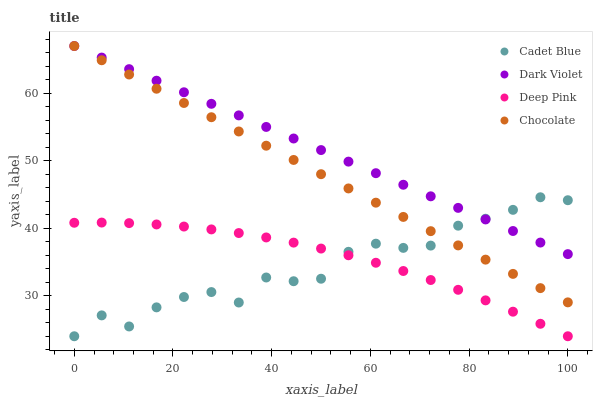Does Cadet Blue have the minimum area under the curve?
Answer yes or no. Yes. Does Dark Violet have the maximum area under the curve?
Answer yes or no. Yes. Does Dark Violet have the minimum area under the curve?
Answer yes or no. No. Does Cadet Blue have the maximum area under the curve?
Answer yes or no. No. Is Chocolate the smoothest?
Answer yes or no. Yes. Is Cadet Blue the roughest?
Answer yes or no. Yes. Is Dark Violet the smoothest?
Answer yes or no. No. Is Dark Violet the roughest?
Answer yes or no. No. Does Cadet Blue have the lowest value?
Answer yes or no. Yes. Does Dark Violet have the lowest value?
Answer yes or no. No. Does Dark Violet have the highest value?
Answer yes or no. Yes. Does Cadet Blue have the highest value?
Answer yes or no. No. Is Deep Pink less than Dark Violet?
Answer yes or no. Yes. Is Dark Violet greater than Deep Pink?
Answer yes or no. Yes. Does Deep Pink intersect Cadet Blue?
Answer yes or no. Yes. Is Deep Pink less than Cadet Blue?
Answer yes or no. No. Is Deep Pink greater than Cadet Blue?
Answer yes or no. No. Does Deep Pink intersect Dark Violet?
Answer yes or no. No. 